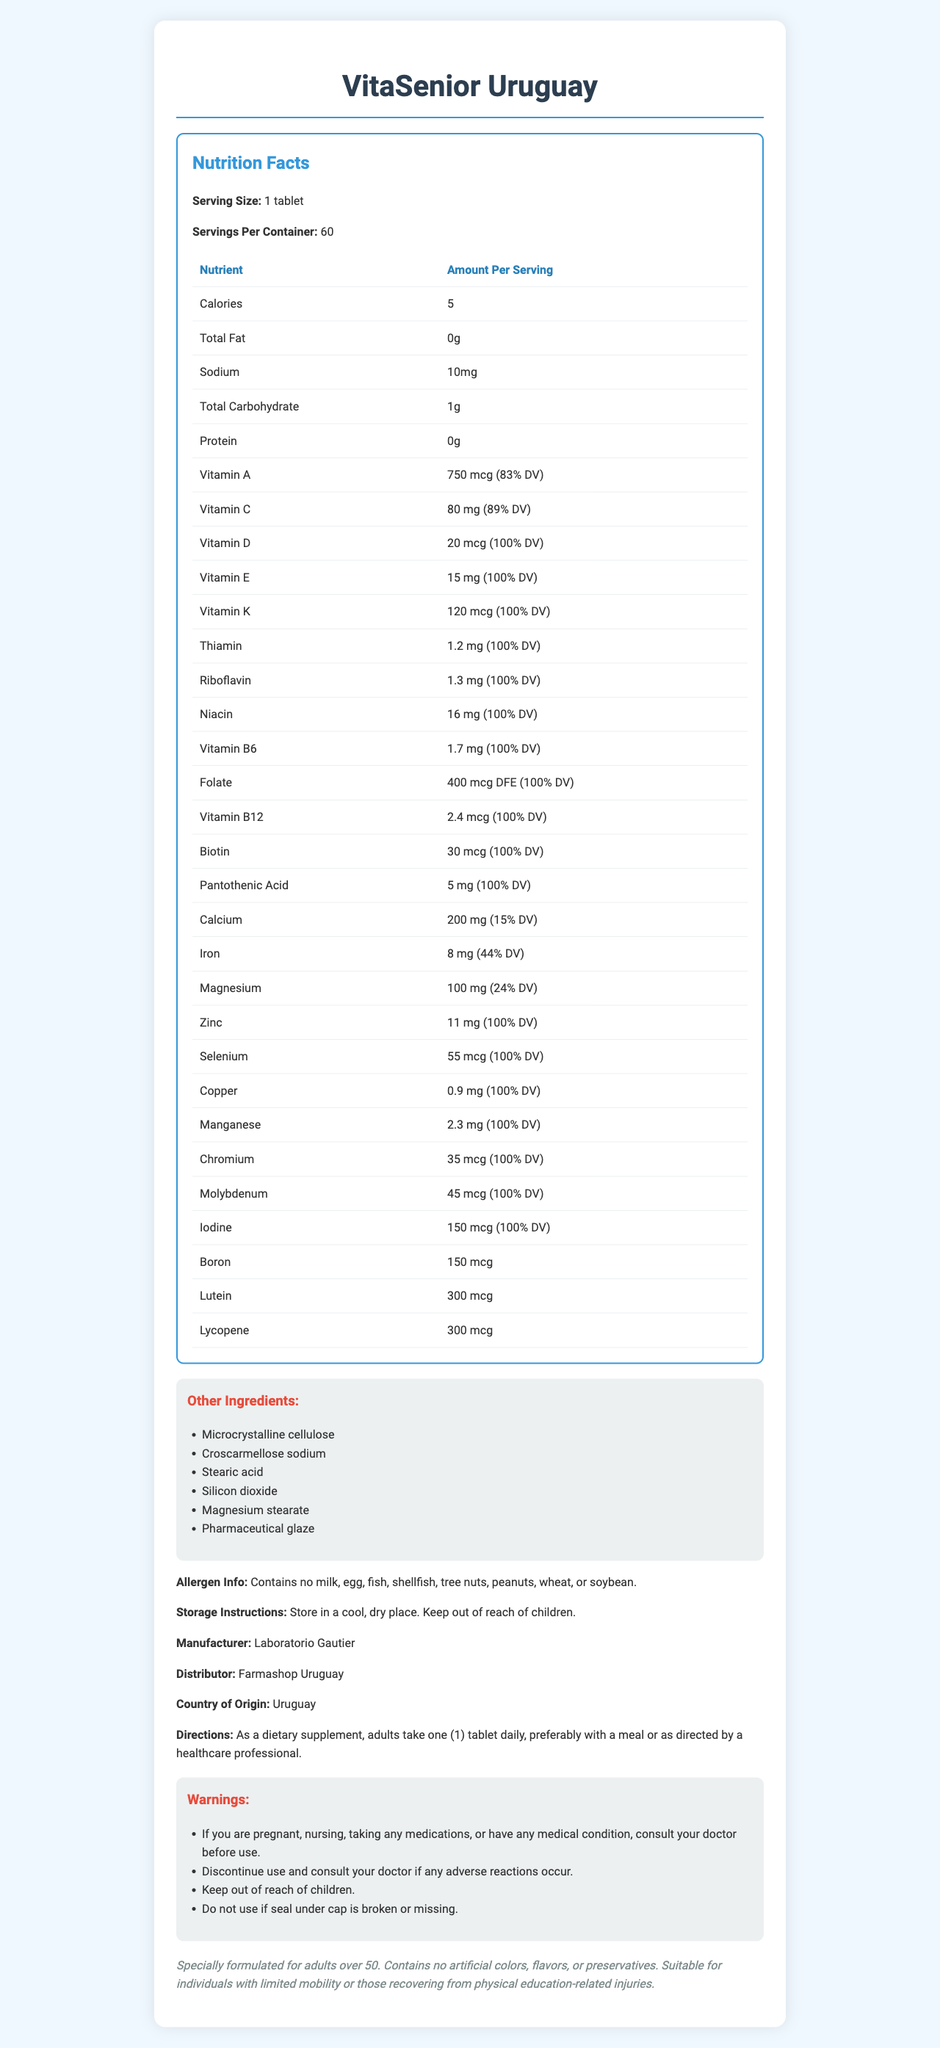what is the serving size? The serving size information is clearly stated at the beginning of the Nutrition Facts section as "Serving Size: 1 tablet."
Answer: 1 tablet how many servings are in one container? The number of servings per container is specified early in the Nutrition Facts section as "Servings Per Container: 60."
Answer: 60 what is the amount of Vitamin C per serving? The amount of Vitamin C per serving is given in the table as "Vitamin C: 80 mg (89% DV)."
Answer: 80 mg how much calcium is in one tablet? The amount of calcium per serving is listed in the table as "Calcium: 200 mg (15% DV)."
Answer: 200 mg what are two of the other ingredients listed? Two of the other ingredients are listed in the section titled "Other Ingredients" and include "Microcrystalline cellulose" and "Stearic acid."
Answer: Microcrystalline cellulose, Stearic acid which of the following vitamins has a listed amount of 100% Daily Value (DV)?
A. Vitamin A
B. Vitamin D
C. Vitamin E Vitamin E is listed with an amount of 100% DV, while Vitamin A and Vitamin D have different percentages.
Answer: C what is the minimum age group recommended for this supplement? 
A. 20 years
B. 30 years
C. 50 years The document states that the supplement is "specially formulated for adults over 50."
Answer: C does VitaSenior Uruguay contain any tree nuts or peanuts? The allergen information clearly states that the product contains no tree nuts or peanuts.
Answer: No is it necessary to store the supplement in a warm place? The storage instructions advise storing the supplement in a "cool, dry place."
Answer: No describe the purpose and main content of the VitaSenior Uruguay document. The explanation outlines that the document contains the nutritional details, ingredient list, storage instructions, allergen information, manufacturer and distributor details, usage directions, and warnings related to the multivitamin supplement, highlighting its target audience of adults over 50.
Answer: VitaSenior Uruguay is a multivitamin supplement designed for adults over 50. The document provides detailed nutrition facts, including amounts of various vitamins and minerals per tablet, along with serving size and number of servings per container. It also lists other ingredients, storage instructions, allergen information, and warnings regarding its use. Additionally, it specifies directions for how to take the supplement and provides contact information for the manufacturer and distributor. what is the percentage daily value of iron per tablet? The iron content is shown in the table as "Iron: 8 mg (44% DV)."
Answer: 44% how many micrograms of lutein does one tablet contain? The amount of lutein per tablet is given in the table as "Lutein: 300 mcg."
Answer: 300 mcg what is the manufacturing location of VitaSenior Uruguay? The document states that the country of origin is Uruguay.
Answer: Uruguay can VitaSenior Uruguay tablets be taken on an empty stomach? The directions suggest taking one tablet daily, preferably with a meal, but do not provide enough information about taking it on an empty stomach.
Answer: Not enough information 